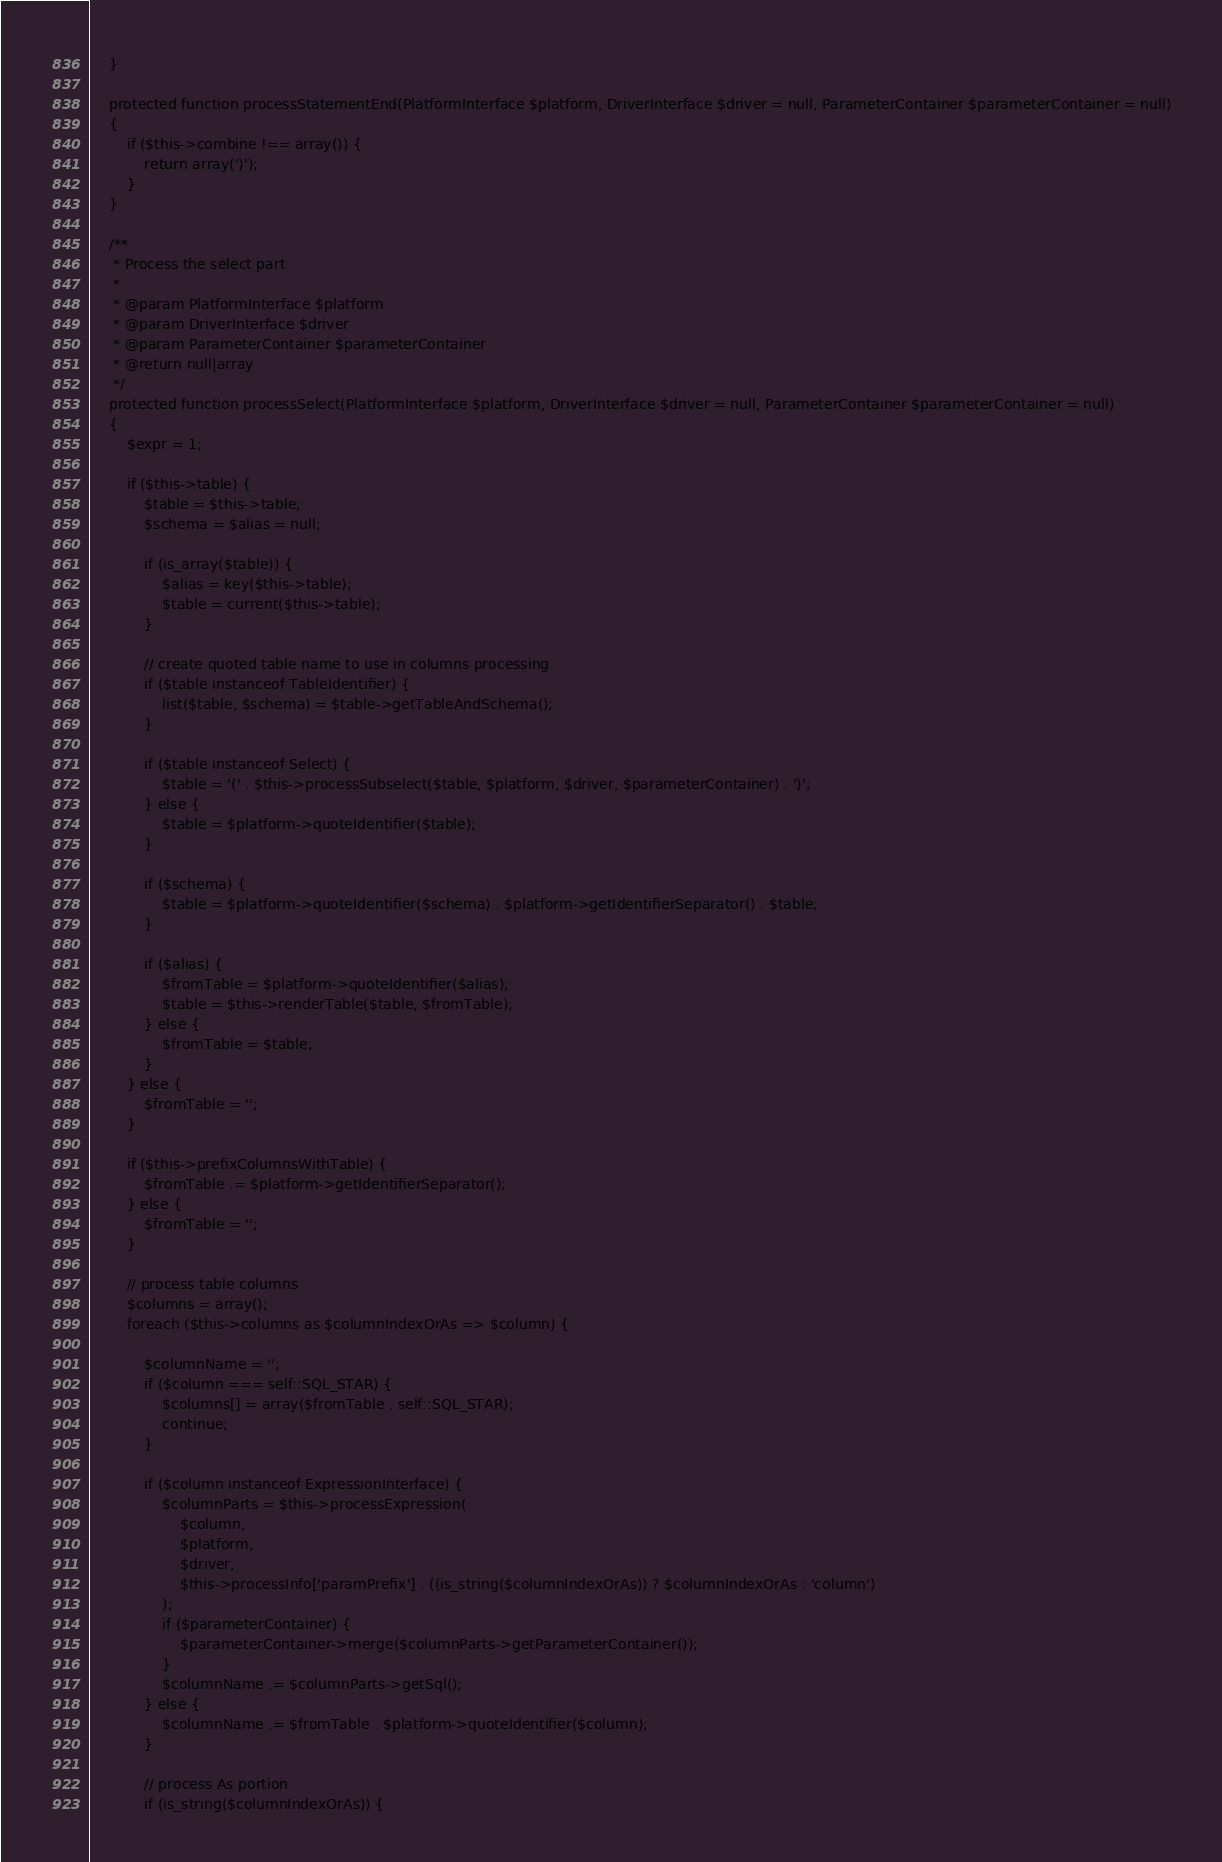Convert code to text. <code><loc_0><loc_0><loc_500><loc_500><_PHP_>    }

    protected function processStatementEnd(PlatformInterface $platform, DriverInterface $driver = null, ParameterContainer $parameterContainer = null)
    {
        if ($this->combine !== array()) {
            return array(')');
        }
    }

    /**
     * Process the select part
     *
     * @param PlatformInterface $platform
     * @param DriverInterface $driver
     * @param ParameterContainer $parameterContainer
     * @return null|array
     */
    protected function processSelect(PlatformInterface $platform, DriverInterface $driver = null, ParameterContainer $parameterContainer = null)
    {
        $expr = 1;

        if ($this->table) {
            $table = $this->table;
            $schema = $alias = null;

            if (is_array($table)) {
                $alias = key($this->table);
                $table = current($this->table);
            }

            // create quoted table name to use in columns processing
            if ($table instanceof TableIdentifier) {
                list($table, $schema) = $table->getTableAndSchema();
            }

            if ($table instanceof Select) {
                $table = '(' . $this->processSubselect($table, $platform, $driver, $parameterContainer) . ')';
            } else {
                $table = $platform->quoteIdentifier($table);
            }

            if ($schema) {
                $table = $platform->quoteIdentifier($schema) . $platform->getIdentifierSeparator() . $table;
            }

            if ($alias) {
                $fromTable = $platform->quoteIdentifier($alias);
                $table = $this->renderTable($table, $fromTable);
            } else {
                $fromTable = $table;
            }
        } else {
            $fromTable = '';
        }

        if ($this->prefixColumnsWithTable) {
            $fromTable .= $platform->getIdentifierSeparator();
        } else {
            $fromTable = '';
        }

        // process table columns
        $columns = array();
        foreach ($this->columns as $columnIndexOrAs => $column) {

            $columnName = '';
            if ($column === self::SQL_STAR) {
                $columns[] = array($fromTable . self::SQL_STAR);
                continue;
            }

            if ($column instanceof ExpressionInterface) {
                $columnParts = $this->processExpression(
                    $column,
                    $platform,
                    $driver,
                    $this->processInfo['paramPrefix'] . ((is_string($columnIndexOrAs)) ? $columnIndexOrAs : 'column')
                );
                if ($parameterContainer) {
                    $parameterContainer->merge($columnParts->getParameterContainer());
                }
                $columnName .= $columnParts->getSql();
            } else {
                $columnName .= $fromTable . $platform->quoteIdentifier($column);
            }

            // process As portion
            if (is_string($columnIndexOrAs)) {</code> 